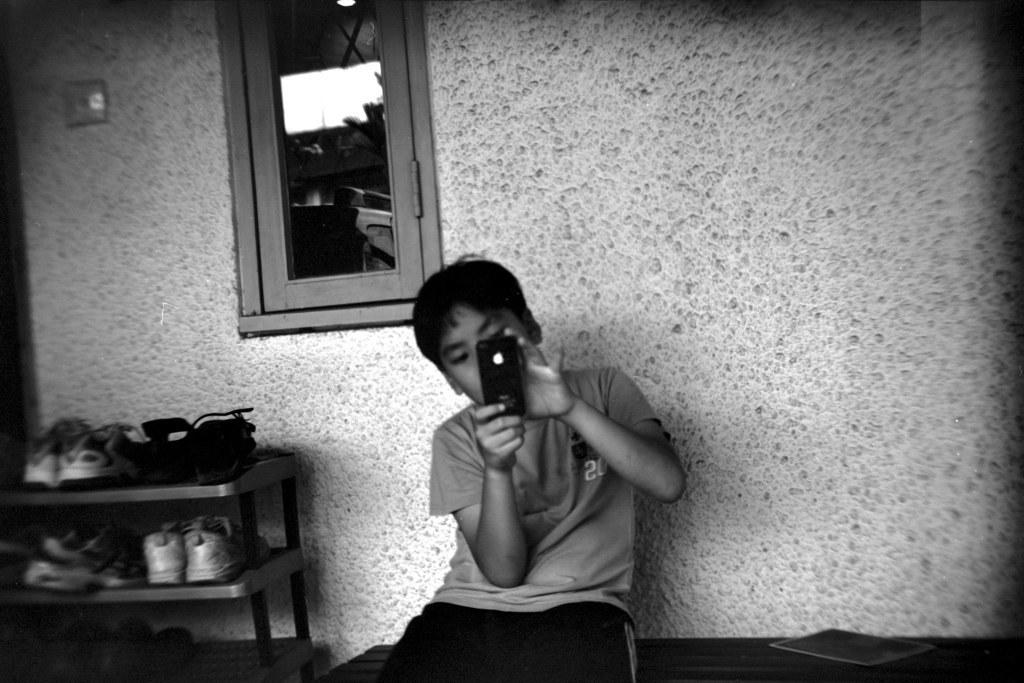What objects can be seen in the image? There are shoes and a boy sitting on a bench in the image. What is the boy holding? The boy is holding a mobile. What type of structure is visible in the image? There is a glass window in the image. How many geese are visible through the glass window in the image? There are no geese visible through the glass window in the image. What type of muscle is the boy exercising while sitting on the bench? The boy is not exercising any muscles in the image; he is simply sitting on the bench. 